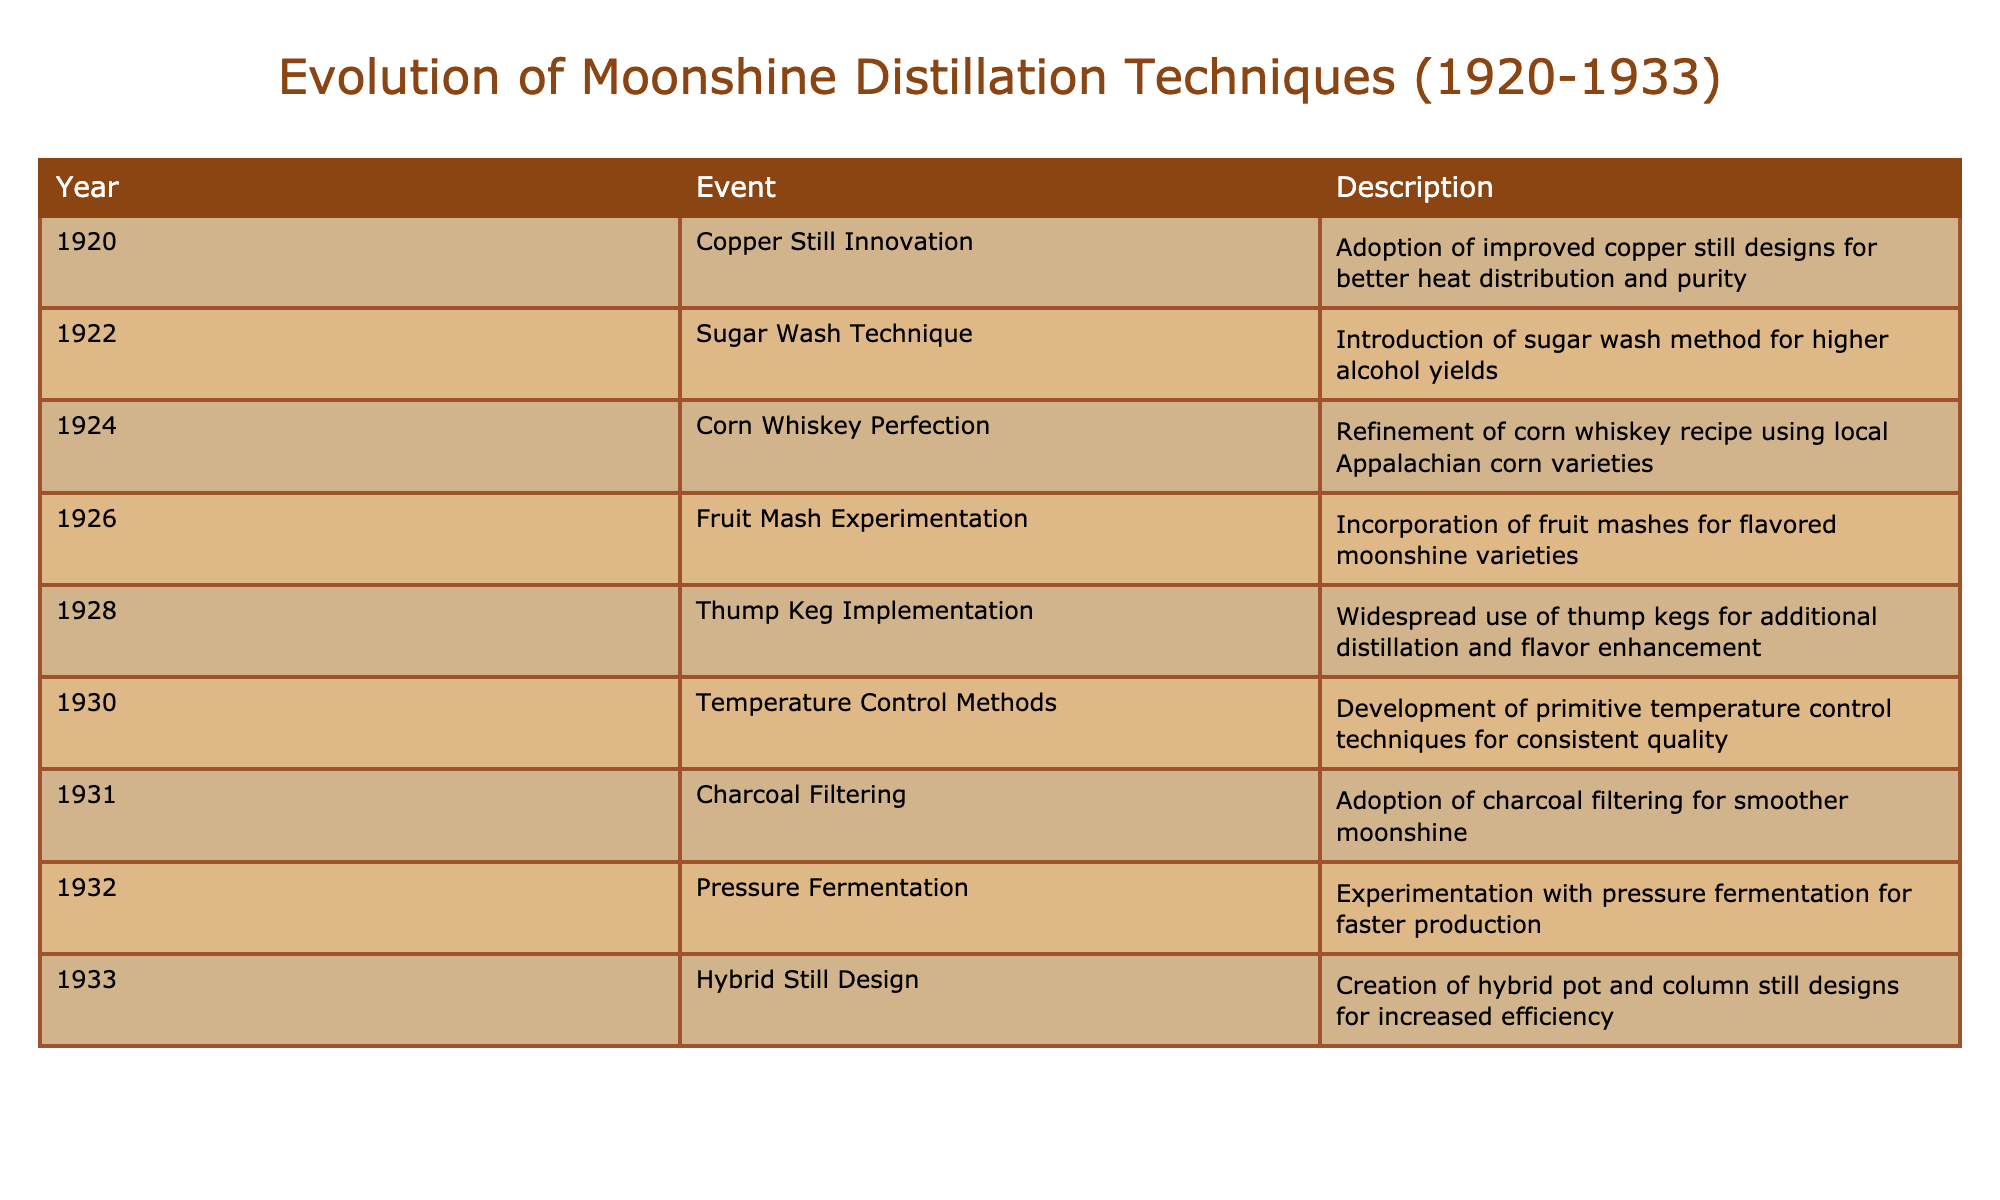What year did the Copper Still Innovation occur? The table lists the event "Copper Still Innovation" which occurred in the year 1920. Simply locating this event in the "Event" column and reading the corresponding "Year" column gives the answer.
Answer: 1920 What technique was introduced in 1922? By looking at the year 1922 in the table, we can find the event listed as "Sugar Wash Technique," which indicates this technique was introduced that year.
Answer: Sugar Wash Technique How many events occurred between 1920 and 1926? Counting the events listed from 1920 to 1926 includes the years: 1920, 1922, 1924, and 1926, which total to four events.
Answer: 4 Did the Charcoal Filtering technique get adopted before 1932? Since the event "Charcoal Filtering" is listed under 1931, which is before 1932, the answer is yes, it did get adopted before 1932.
Answer: Yes What was the last technique introduced before Prohibition ended? The last event listed in the table is "Hybrid Still Design" in 1933, and since Prohibition ended that same year, this was the last technique introduced before the end of Prohibition.
Answer: Hybrid Still Design What was the average year of events that involved fermentation techniques? The fermentation techniques are listed as "Sugar Wash Technique" (1922), "Pressure Fermentation" (1932), and "Temperature Control Methods" (1930). Calculating the average: (1922 + 1930 + 1932) / 3 = 1928
Answer: 1928 Was the Thump Keg Implementation before the introduction of Pressure Fermentation? From the table, the event "Thump Keg Implementation" occurred in 1928, and "Pressure Fermentation" occurred in 1932, thus it is true that Thump Keg Implementation came before Pressure Fermentation.
Answer: Yes How many techniques were introduced in the years 1926 and 1928 combined? In 1926, there was "Fruit Mash Experimentation," and in 1928, there was "Thump Keg Implementation." Thus, adding these two gives a total of two techniques combined.
Answer: 2 What distinct innovations occurred within the timeframe of 1924-1930? The events listed between 1924 and 1930 are: "Corn Whiskey Perfection" (1924), "Fruit Mash Experimentation" (1926), and "Temperature Control Methods" (1930). This is a total of three distinct innovations.
Answer: 3 